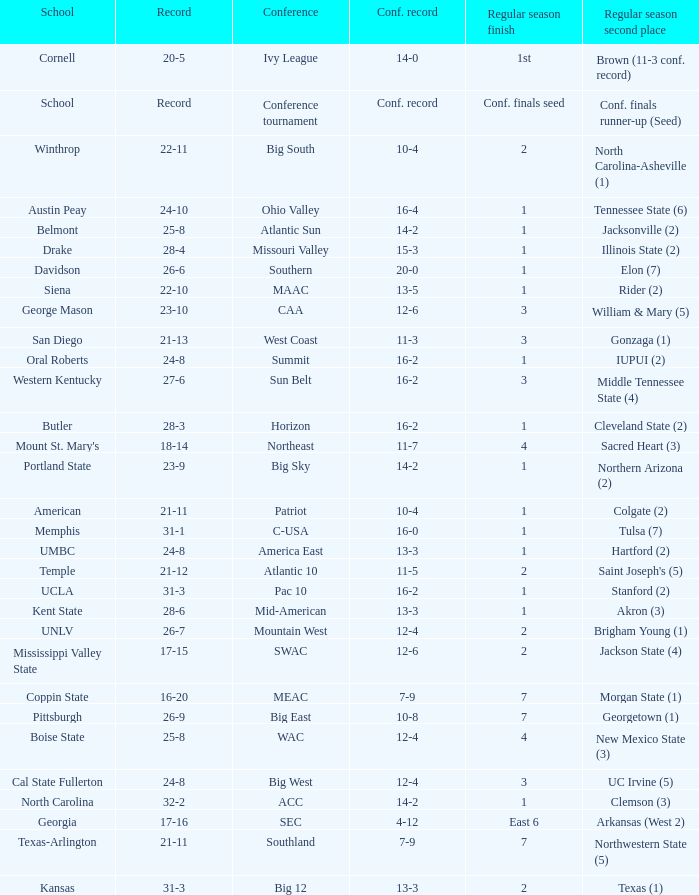In which assembly does belmont participate? Atlantic Sun. 